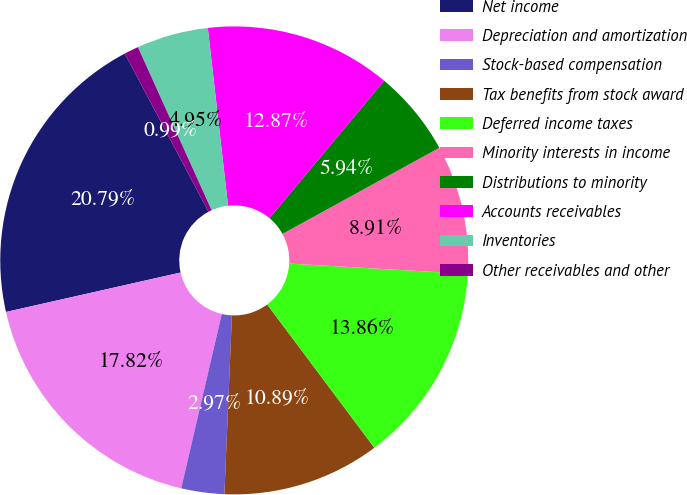<chart> <loc_0><loc_0><loc_500><loc_500><pie_chart><fcel>Net income<fcel>Depreciation and amortization<fcel>Stock-based compensation<fcel>Tax benefits from stock award<fcel>Deferred income taxes<fcel>Minority interests in income<fcel>Distributions to minority<fcel>Accounts receivables<fcel>Inventories<fcel>Other receivables and other<nl><fcel>20.79%<fcel>17.82%<fcel>2.97%<fcel>10.89%<fcel>13.86%<fcel>8.91%<fcel>5.94%<fcel>12.87%<fcel>4.95%<fcel>0.99%<nl></chart> 